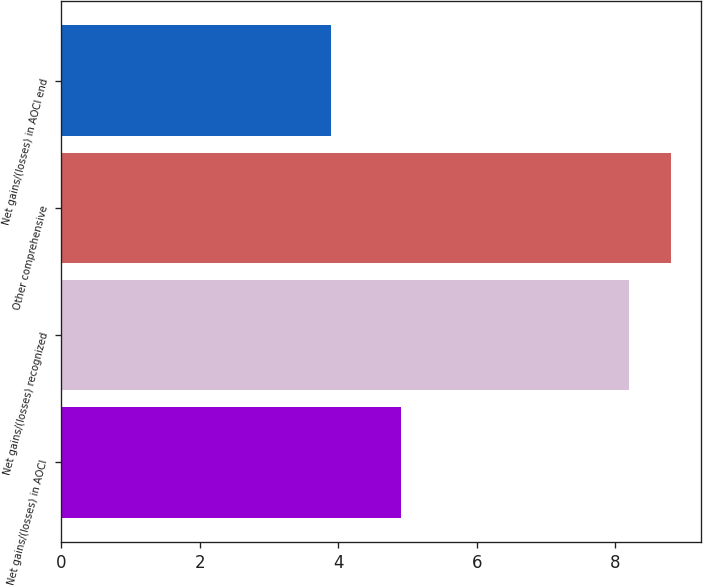<chart> <loc_0><loc_0><loc_500><loc_500><bar_chart><fcel>Net gains/(losses) in AOCI<fcel>Net gains/(losses) recognized<fcel>Other comprehensive<fcel>Net gains/(losses) in AOCI end<nl><fcel>4.9<fcel>8.2<fcel>8.8<fcel>3.9<nl></chart> 